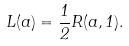<formula> <loc_0><loc_0><loc_500><loc_500>L ( a ) = \frac { 1 } { 2 } R ( a , 1 ) .</formula> 